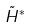<formula> <loc_0><loc_0><loc_500><loc_500>\tilde { H } ^ { * }</formula> 